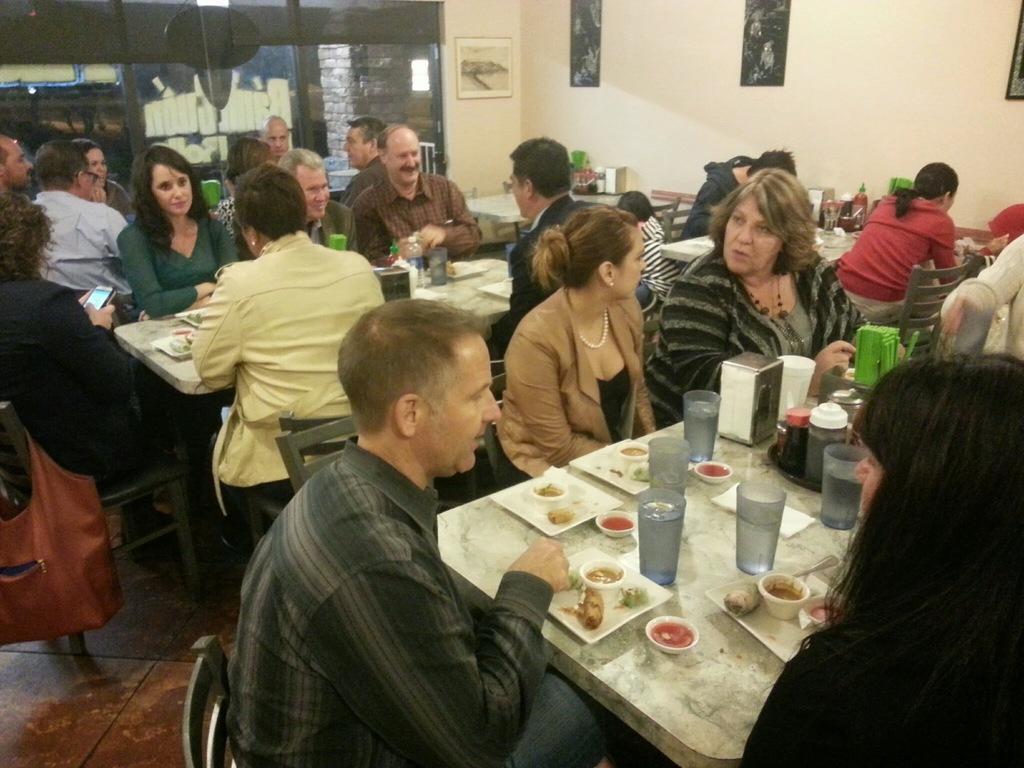In one or two sentences, can you explain what this image depicts? Group of people sitting on the chairs. We can see glasses,plates,food,bowls,ketchup bottle on the tables. On the background we can see wall,frames,glass window. This is floor. 